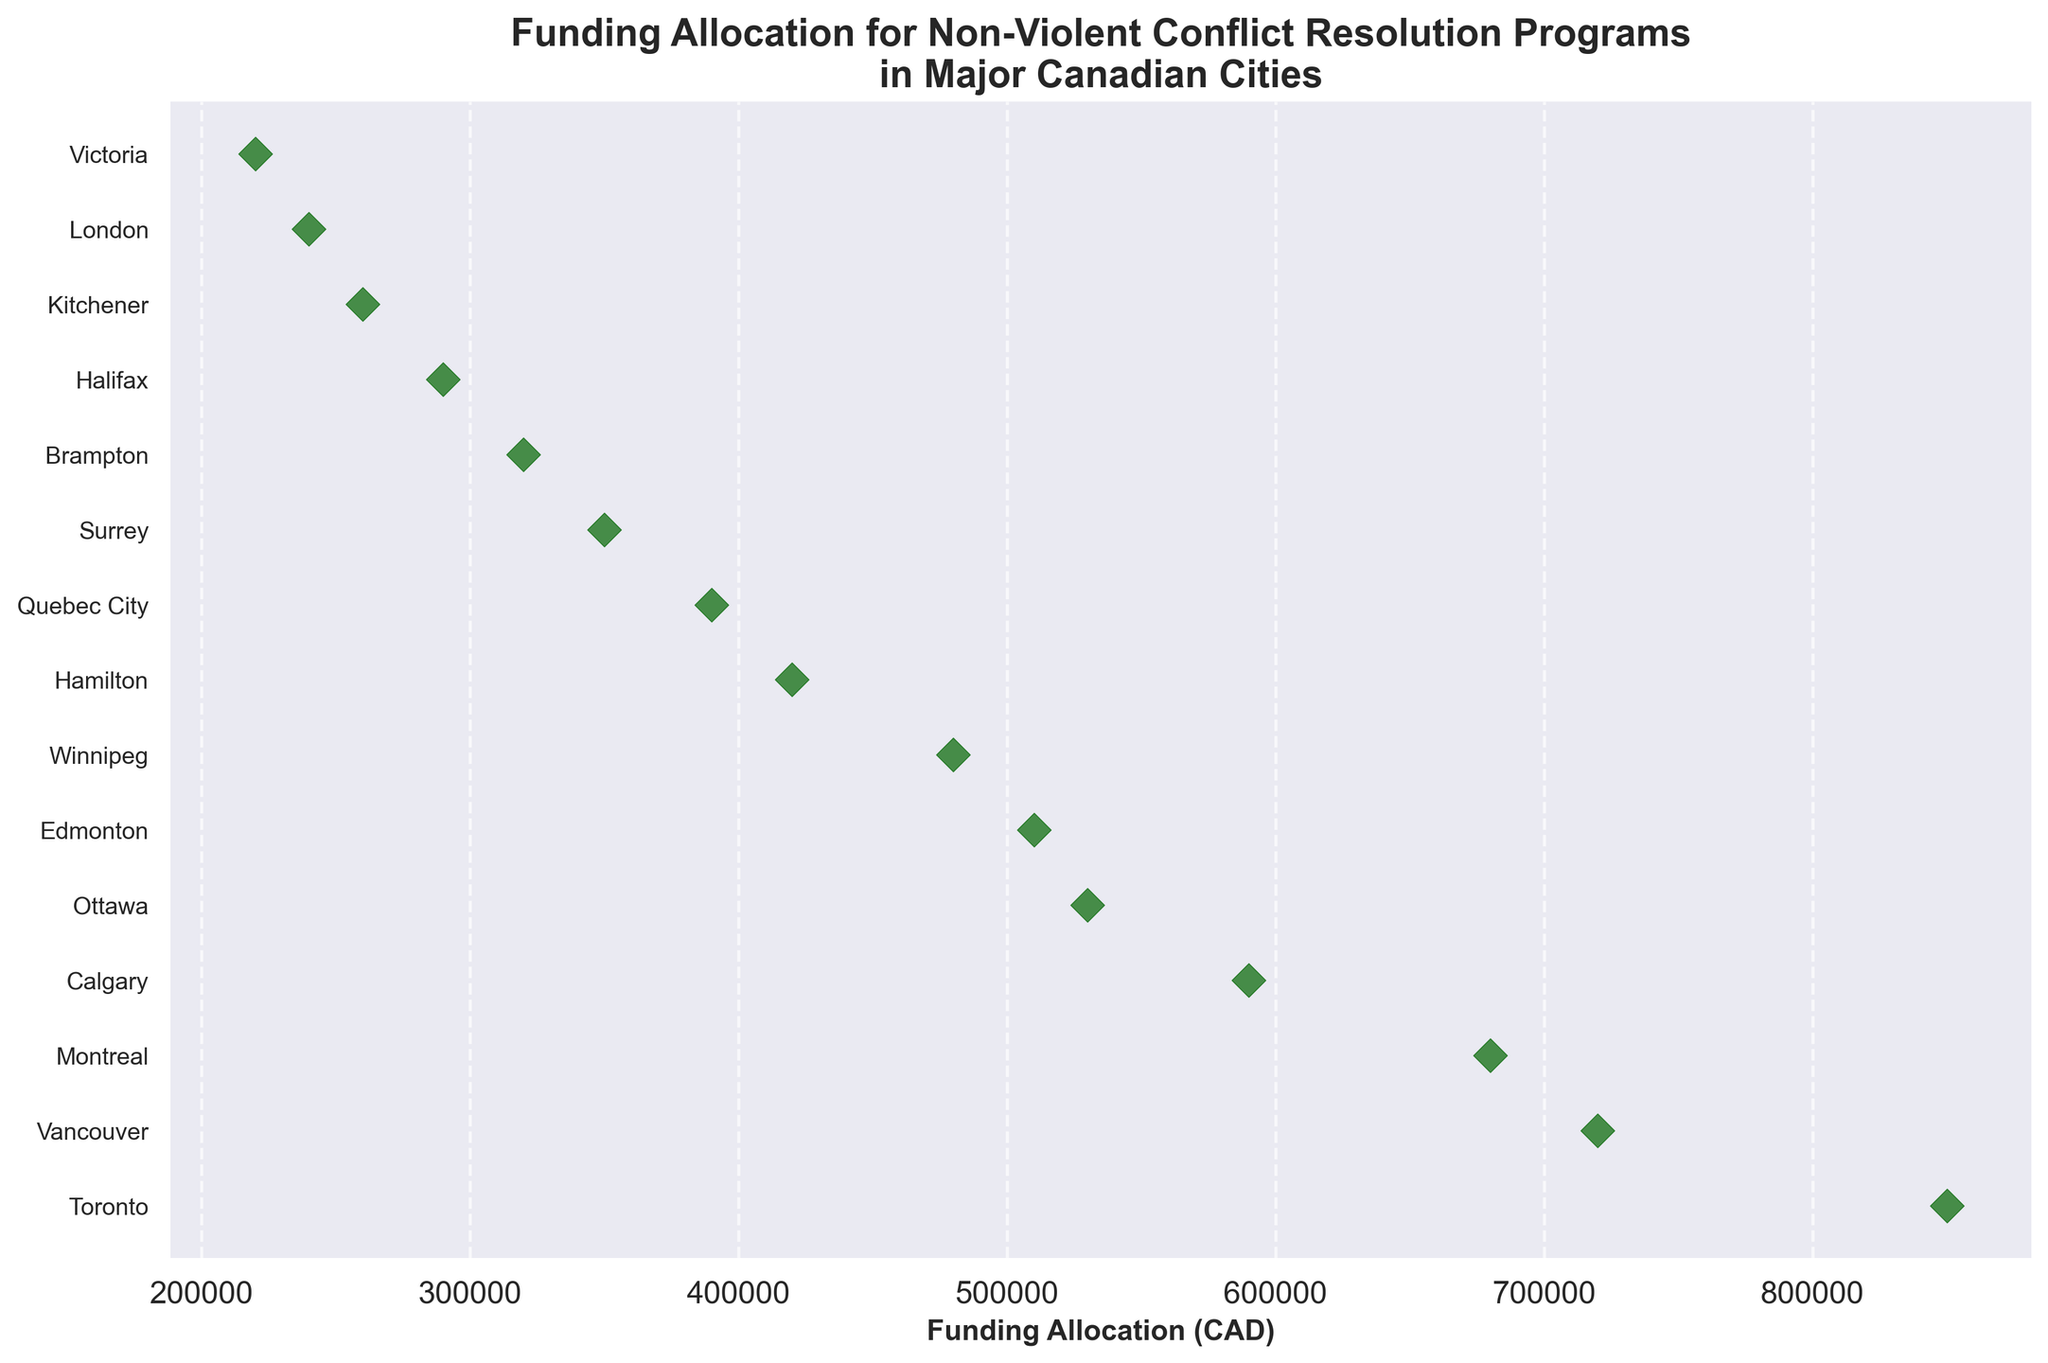What is the title of the plot? The title is found at the top of the plot.
Answer: Funding Allocation for Non-Violent Conflict Resolution Programs in Major Canadian Cities Which city has the highest funding allocation? The city with the highest funding allocation is the one with the data point farthest to the right on the x-axis.
Answer: Toronto What city is allocated $480,000 for funding? Identify the data point that aligns with the $480,000 mark on the x-axis and find the corresponding city on the y-axis.
Answer: Winnipeg How many cities have a funding allocation of more than $500,000? Count the number of data points located to the right of the $500,000 mark on the x-axis.
Answer: 5 Which cities have funding allocations between $300,000 and $400,000? Identify the data points that fall within the $300,000 to $400,000 range on the x-axis and note the corresponding cities on the y-axis.
Answer: Quebec City, Surrey, Brampton What is the total funding allocation for Vancouver and Montreal? Add the funding amounts for Vancouver ($720,000) and Montreal ($680,000).
Answer: $1,400,000 How much more funding does Calgary receive compared to Halifax? Subtract the funding allocation of Halifax from that of Calgary ($590,000 - $290,000).
Answer: $300,000 Which city has the least amount of funding allocated? The city with the least funding is the one with the data point farthest to the left on the x-axis.
Answer: Victoria Are there more cities with funding allocations above or below $500,000? Count the number of data points above and below the $500,000 mark on the x-axis and compare.
Answer: Below How much funding does Ottawa receive compared to Edmonton? Find the funding for Ottawa ($530,000) and Edmonton ($510,000) and compare.
Answer: Ottawa receives $20,000 more than Edmonton 